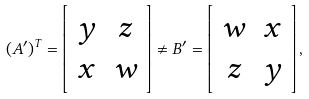<formula> <loc_0><loc_0><loc_500><loc_500>( A ^ { \prime } ) ^ { T } = \left [ \begin{array} { c c } y & z \\ x & w \\ \end{array} \right ] \neq B ^ { \prime } = \left [ \begin{array} { c c } w & x \\ z & y \\ \end{array} \right ] ,</formula> 